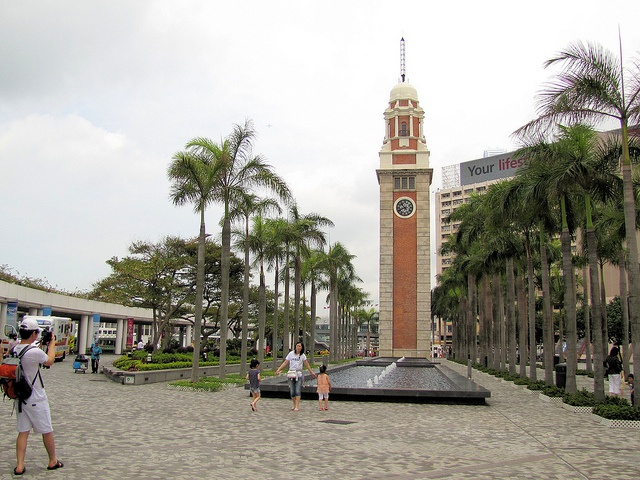Describe the objects in this image and their specific colors. I can see people in lightgray, darkgray, black, and gray tones, backpack in lightgray, black, gray, maroon, and brown tones, people in lightgray, gray, darkgray, and black tones, bus in lightgray, darkgray, gray, and ivory tones, and truck in lightgray, darkgray, gray, and ivory tones in this image. 